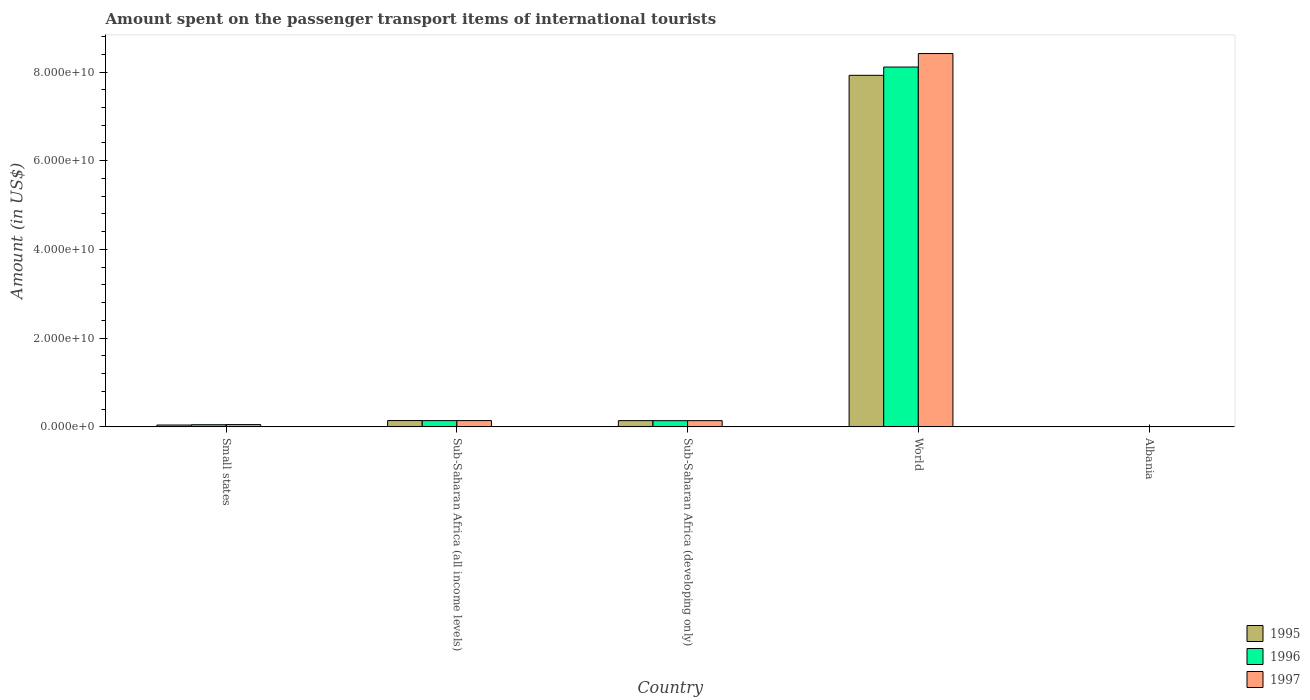Are the number of bars on each tick of the X-axis equal?
Make the answer very short. Yes. What is the label of the 1st group of bars from the left?
Ensure brevity in your answer.  Small states. In how many cases, is the number of bars for a given country not equal to the number of legend labels?
Ensure brevity in your answer.  0. What is the amount spent on the passenger transport items of international tourists in 1996 in World?
Give a very brief answer. 8.11e+1. Across all countries, what is the maximum amount spent on the passenger transport items of international tourists in 1997?
Your answer should be very brief. 8.42e+1. Across all countries, what is the minimum amount spent on the passenger transport items of international tourists in 1996?
Ensure brevity in your answer.  1.30e+07. In which country was the amount spent on the passenger transport items of international tourists in 1997 minimum?
Your answer should be very brief. Albania. What is the total amount spent on the passenger transport items of international tourists in 1995 in the graph?
Ensure brevity in your answer.  8.25e+1. What is the difference between the amount spent on the passenger transport items of international tourists in 1997 in Albania and that in Sub-Saharan Africa (developing only)?
Ensure brevity in your answer.  -1.39e+09. What is the difference between the amount spent on the passenger transport items of international tourists in 1995 in Albania and the amount spent on the passenger transport items of international tourists in 1996 in Sub-Saharan Africa (all income levels)?
Your answer should be compact. -1.40e+09. What is the average amount spent on the passenger transport items of international tourists in 1997 per country?
Provide a short and direct response. 1.75e+1. What is the difference between the amount spent on the passenger transport items of international tourists of/in 1995 and amount spent on the passenger transport items of international tourists of/in 1997 in Small states?
Make the answer very short. -9.94e+07. What is the ratio of the amount spent on the passenger transport items of international tourists in 1996 in Albania to that in World?
Your answer should be compact. 0. Is the amount spent on the passenger transport items of international tourists in 1997 in Sub-Saharan Africa (all income levels) less than that in World?
Provide a short and direct response. Yes. What is the difference between the highest and the second highest amount spent on the passenger transport items of international tourists in 1997?
Your answer should be very brief. 8.27e+1. What is the difference between the highest and the lowest amount spent on the passenger transport items of international tourists in 1996?
Your response must be concise. 8.11e+1. In how many countries, is the amount spent on the passenger transport items of international tourists in 1995 greater than the average amount spent on the passenger transport items of international tourists in 1995 taken over all countries?
Provide a short and direct response. 1. What does the 2nd bar from the left in Small states represents?
Your answer should be very brief. 1996. How many bars are there?
Make the answer very short. 15. Are all the bars in the graph horizontal?
Make the answer very short. No. How many countries are there in the graph?
Your answer should be very brief. 5. What is the difference between two consecutive major ticks on the Y-axis?
Give a very brief answer. 2.00e+1. Does the graph contain any zero values?
Ensure brevity in your answer.  No. Does the graph contain grids?
Provide a short and direct response. No. What is the title of the graph?
Offer a terse response. Amount spent on the passenger transport items of international tourists. What is the label or title of the X-axis?
Keep it short and to the point. Country. What is the label or title of the Y-axis?
Provide a succinct answer. Amount (in US$). What is the Amount (in US$) of 1995 in Small states?
Offer a terse response. 4.15e+08. What is the Amount (in US$) of 1996 in Small states?
Provide a short and direct response. 4.85e+08. What is the Amount (in US$) of 1997 in Small states?
Offer a very short reply. 5.15e+08. What is the Amount (in US$) of 1995 in Sub-Saharan Africa (all income levels)?
Offer a terse response. 1.42e+09. What is the Amount (in US$) of 1996 in Sub-Saharan Africa (all income levels)?
Provide a succinct answer. 1.41e+09. What is the Amount (in US$) of 1997 in Sub-Saharan Africa (all income levels)?
Keep it short and to the point. 1.42e+09. What is the Amount (in US$) of 1995 in Sub-Saharan Africa (developing only)?
Provide a succinct answer. 1.41e+09. What is the Amount (in US$) of 1996 in Sub-Saharan Africa (developing only)?
Keep it short and to the point. 1.40e+09. What is the Amount (in US$) of 1997 in Sub-Saharan Africa (developing only)?
Offer a terse response. 1.40e+09. What is the Amount (in US$) of 1995 in World?
Offer a terse response. 7.93e+1. What is the Amount (in US$) of 1996 in World?
Your answer should be compact. 8.11e+1. What is the Amount (in US$) of 1997 in World?
Provide a short and direct response. 8.42e+1. What is the Amount (in US$) of 1995 in Albania?
Provide a short and direct response. 1.20e+07. What is the Amount (in US$) in 1996 in Albania?
Keep it short and to the point. 1.30e+07. Across all countries, what is the maximum Amount (in US$) of 1995?
Provide a succinct answer. 7.93e+1. Across all countries, what is the maximum Amount (in US$) in 1996?
Ensure brevity in your answer.  8.11e+1. Across all countries, what is the maximum Amount (in US$) of 1997?
Your response must be concise. 8.42e+1. Across all countries, what is the minimum Amount (in US$) in 1996?
Make the answer very short. 1.30e+07. What is the total Amount (in US$) of 1995 in the graph?
Your answer should be compact. 8.25e+1. What is the total Amount (in US$) in 1996 in the graph?
Ensure brevity in your answer.  8.44e+1. What is the total Amount (in US$) in 1997 in the graph?
Your answer should be very brief. 8.75e+1. What is the difference between the Amount (in US$) in 1995 in Small states and that in Sub-Saharan Africa (all income levels)?
Your response must be concise. -1.01e+09. What is the difference between the Amount (in US$) of 1996 in Small states and that in Sub-Saharan Africa (all income levels)?
Your answer should be very brief. -9.28e+08. What is the difference between the Amount (in US$) in 1997 in Small states and that in Sub-Saharan Africa (all income levels)?
Your answer should be very brief. -9.01e+08. What is the difference between the Amount (in US$) in 1995 in Small states and that in Sub-Saharan Africa (developing only)?
Your answer should be very brief. -9.90e+08. What is the difference between the Amount (in US$) of 1996 in Small states and that in Sub-Saharan Africa (developing only)?
Give a very brief answer. -9.14e+08. What is the difference between the Amount (in US$) of 1997 in Small states and that in Sub-Saharan Africa (developing only)?
Ensure brevity in your answer.  -8.87e+08. What is the difference between the Amount (in US$) of 1995 in Small states and that in World?
Provide a succinct answer. -7.88e+1. What is the difference between the Amount (in US$) in 1996 in Small states and that in World?
Give a very brief answer. -8.06e+1. What is the difference between the Amount (in US$) of 1997 in Small states and that in World?
Your response must be concise. -8.36e+1. What is the difference between the Amount (in US$) in 1995 in Small states and that in Albania?
Keep it short and to the point. 4.03e+08. What is the difference between the Amount (in US$) of 1996 in Small states and that in Albania?
Provide a short and direct response. 4.72e+08. What is the difference between the Amount (in US$) of 1997 in Small states and that in Albania?
Your answer should be very brief. 5.07e+08. What is the difference between the Amount (in US$) in 1995 in Sub-Saharan Africa (all income levels) and that in Sub-Saharan Africa (developing only)?
Keep it short and to the point. 1.78e+07. What is the difference between the Amount (in US$) in 1996 in Sub-Saharan Africa (all income levels) and that in Sub-Saharan Africa (developing only)?
Ensure brevity in your answer.  1.43e+07. What is the difference between the Amount (in US$) of 1997 in Sub-Saharan Africa (all income levels) and that in Sub-Saharan Africa (developing only)?
Make the answer very short. 1.43e+07. What is the difference between the Amount (in US$) of 1995 in Sub-Saharan Africa (all income levels) and that in World?
Offer a terse response. -7.78e+1. What is the difference between the Amount (in US$) in 1996 in Sub-Saharan Africa (all income levels) and that in World?
Give a very brief answer. -7.97e+1. What is the difference between the Amount (in US$) in 1997 in Sub-Saharan Africa (all income levels) and that in World?
Your answer should be very brief. -8.27e+1. What is the difference between the Amount (in US$) of 1995 in Sub-Saharan Africa (all income levels) and that in Albania?
Keep it short and to the point. 1.41e+09. What is the difference between the Amount (in US$) in 1996 in Sub-Saharan Africa (all income levels) and that in Albania?
Offer a terse response. 1.40e+09. What is the difference between the Amount (in US$) in 1997 in Sub-Saharan Africa (all income levels) and that in Albania?
Your response must be concise. 1.41e+09. What is the difference between the Amount (in US$) of 1995 in Sub-Saharan Africa (developing only) and that in World?
Keep it short and to the point. -7.78e+1. What is the difference between the Amount (in US$) in 1996 in Sub-Saharan Africa (developing only) and that in World?
Your answer should be very brief. -7.97e+1. What is the difference between the Amount (in US$) of 1997 in Sub-Saharan Africa (developing only) and that in World?
Keep it short and to the point. -8.28e+1. What is the difference between the Amount (in US$) of 1995 in Sub-Saharan Africa (developing only) and that in Albania?
Give a very brief answer. 1.39e+09. What is the difference between the Amount (in US$) of 1996 in Sub-Saharan Africa (developing only) and that in Albania?
Offer a terse response. 1.39e+09. What is the difference between the Amount (in US$) of 1997 in Sub-Saharan Africa (developing only) and that in Albania?
Your answer should be very brief. 1.39e+09. What is the difference between the Amount (in US$) of 1995 in World and that in Albania?
Provide a short and direct response. 7.92e+1. What is the difference between the Amount (in US$) in 1996 in World and that in Albania?
Offer a terse response. 8.11e+1. What is the difference between the Amount (in US$) in 1997 in World and that in Albania?
Give a very brief answer. 8.42e+1. What is the difference between the Amount (in US$) in 1995 in Small states and the Amount (in US$) in 1996 in Sub-Saharan Africa (all income levels)?
Provide a short and direct response. -9.98e+08. What is the difference between the Amount (in US$) of 1995 in Small states and the Amount (in US$) of 1997 in Sub-Saharan Africa (all income levels)?
Give a very brief answer. -1.00e+09. What is the difference between the Amount (in US$) in 1996 in Small states and the Amount (in US$) in 1997 in Sub-Saharan Africa (all income levels)?
Give a very brief answer. -9.31e+08. What is the difference between the Amount (in US$) in 1995 in Small states and the Amount (in US$) in 1996 in Sub-Saharan Africa (developing only)?
Offer a terse response. -9.84e+08. What is the difference between the Amount (in US$) in 1995 in Small states and the Amount (in US$) in 1997 in Sub-Saharan Africa (developing only)?
Give a very brief answer. -9.86e+08. What is the difference between the Amount (in US$) in 1996 in Small states and the Amount (in US$) in 1997 in Sub-Saharan Africa (developing only)?
Your answer should be compact. -9.17e+08. What is the difference between the Amount (in US$) of 1995 in Small states and the Amount (in US$) of 1996 in World?
Offer a very short reply. -8.07e+1. What is the difference between the Amount (in US$) in 1995 in Small states and the Amount (in US$) in 1997 in World?
Your answer should be very brief. -8.37e+1. What is the difference between the Amount (in US$) in 1996 in Small states and the Amount (in US$) in 1997 in World?
Make the answer very short. -8.37e+1. What is the difference between the Amount (in US$) in 1995 in Small states and the Amount (in US$) in 1996 in Albania?
Give a very brief answer. 4.02e+08. What is the difference between the Amount (in US$) of 1995 in Small states and the Amount (in US$) of 1997 in Albania?
Make the answer very short. 4.07e+08. What is the difference between the Amount (in US$) of 1996 in Small states and the Amount (in US$) of 1997 in Albania?
Give a very brief answer. 4.77e+08. What is the difference between the Amount (in US$) in 1995 in Sub-Saharan Africa (all income levels) and the Amount (in US$) in 1996 in Sub-Saharan Africa (developing only)?
Your answer should be compact. 2.39e+07. What is the difference between the Amount (in US$) in 1995 in Sub-Saharan Africa (all income levels) and the Amount (in US$) in 1997 in Sub-Saharan Africa (developing only)?
Your answer should be very brief. 2.14e+07. What is the difference between the Amount (in US$) in 1996 in Sub-Saharan Africa (all income levels) and the Amount (in US$) in 1997 in Sub-Saharan Africa (developing only)?
Make the answer very short. 1.18e+07. What is the difference between the Amount (in US$) in 1995 in Sub-Saharan Africa (all income levels) and the Amount (in US$) in 1996 in World?
Provide a succinct answer. -7.97e+1. What is the difference between the Amount (in US$) in 1995 in Sub-Saharan Africa (all income levels) and the Amount (in US$) in 1997 in World?
Your answer should be very brief. -8.27e+1. What is the difference between the Amount (in US$) in 1996 in Sub-Saharan Africa (all income levels) and the Amount (in US$) in 1997 in World?
Offer a very short reply. -8.27e+1. What is the difference between the Amount (in US$) of 1995 in Sub-Saharan Africa (all income levels) and the Amount (in US$) of 1996 in Albania?
Keep it short and to the point. 1.41e+09. What is the difference between the Amount (in US$) in 1995 in Sub-Saharan Africa (all income levels) and the Amount (in US$) in 1997 in Albania?
Ensure brevity in your answer.  1.42e+09. What is the difference between the Amount (in US$) of 1996 in Sub-Saharan Africa (all income levels) and the Amount (in US$) of 1997 in Albania?
Your response must be concise. 1.41e+09. What is the difference between the Amount (in US$) in 1995 in Sub-Saharan Africa (developing only) and the Amount (in US$) in 1996 in World?
Ensure brevity in your answer.  -7.97e+1. What is the difference between the Amount (in US$) in 1995 in Sub-Saharan Africa (developing only) and the Amount (in US$) in 1997 in World?
Give a very brief answer. -8.28e+1. What is the difference between the Amount (in US$) of 1996 in Sub-Saharan Africa (developing only) and the Amount (in US$) of 1997 in World?
Give a very brief answer. -8.28e+1. What is the difference between the Amount (in US$) of 1995 in Sub-Saharan Africa (developing only) and the Amount (in US$) of 1996 in Albania?
Make the answer very short. 1.39e+09. What is the difference between the Amount (in US$) in 1995 in Sub-Saharan Africa (developing only) and the Amount (in US$) in 1997 in Albania?
Give a very brief answer. 1.40e+09. What is the difference between the Amount (in US$) in 1996 in Sub-Saharan Africa (developing only) and the Amount (in US$) in 1997 in Albania?
Your response must be concise. 1.39e+09. What is the difference between the Amount (in US$) in 1995 in World and the Amount (in US$) in 1996 in Albania?
Your response must be concise. 7.92e+1. What is the difference between the Amount (in US$) of 1995 in World and the Amount (in US$) of 1997 in Albania?
Make the answer very short. 7.92e+1. What is the difference between the Amount (in US$) of 1996 in World and the Amount (in US$) of 1997 in Albania?
Your answer should be very brief. 8.11e+1. What is the average Amount (in US$) of 1995 per country?
Ensure brevity in your answer.  1.65e+1. What is the average Amount (in US$) of 1996 per country?
Offer a very short reply. 1.69e+1. What is the average Amount (in US$) of 1997 per country?
Provide a short and direct response. 1.75e+1. What is the difference between the Amount (in US$) of 1995 and Amount (in US$) of 1996 in Small states?
Offer a terse response. -6.97e+07. What is the difference between the Amount (in US$) of 1995 and Amount (in US$) of 1997 in Small states?
Offer a very short reply. -9.94e+07. What is the difference between the Amount (in US$) of 1996 and Amount (in US$) of 1997 in Small states?
Your answer should be very brief. -2.97e+07. What is the difference between the Amount (in US$) in 1995 and Amount (in US$) in 1996 in Sub-Saharan Africa (all income levels)?
Offer a terse response. 9.58e+06. What is the difference between the Amount (in US$) in 1995 and Amount (in US$) in 1997 in Sub-Saharan Africa (all income levels)?
Your response must be concise. 7.08e+06. What is the difference between the Amount (in US$) in 1996 and Amount (in US$) in 1997 in Sub-Saharan Africa (all income levels)?
Keep it short and to the point. -2.51e+06. What is the difference between the Amount (in US$) in 1995 and Amount (in US$) in 1996 in Sub-Saharan Africa (developing only)?
Offer a very short reply. 6.01e+06. What is the difference between the Amount (in US$) of 1995 and Amount (in US$) of 1997 in Sub-Saharan Africa (developing only)?
Ensure brevity in your answer.  3.52e+06. What is the difference between the Amount (in US$) in 1996 and Amount (in US$) in 1997 in Sub-Saharan Africa (developing only)?
Give a very brief answer. -2.49e+06. What is the difference between the Amount (in US$) in 1995 and Amount (in US$) in 1996 in World?
Your answer should be compact. -1.87e+09. What is the difference between the Amount (in US$) in 1995 and Amount (in US$) in 1997 in World?
Provide a short and direct response. -4.91e+09. What is the difference between the Amount (in US$) of 1996 and Amount (in US$) of 1997 in World?
Your response must be concise. -3.04e+09. What is the difference between the Amount (in US$) of 1995 and Amount (in US$) of 1997 in Albania?
Give a very brief answer. 4.00e+06. What is the difference between the Amount (in US$) of 1996 and Amount (in US$) of 1997 in Albania?
Make the answer very short. 5.00e+06. What is the ratio of the Amount (in US$) of 1995 in Small states to that in Sub-Saharan Africa (all income levels)?
Your answer should be very brief. 0.29. What is the ratio of the Amount (in US$) of 1996 in Small states to that in Sub-Saharan Africa (all income levels)?
Offer a very short reply. 0.34. What is the ratio of the Amount (in US$) of 1997 in Small states to that in Sub-Saharan Africa (all income levels)?
Provide a succinct answer. 0.36. What is the ratio of the Amount (in US$) in 1995 in Small states to that in Sub-Saharan Africa (developing only)?
Provide a succinct answer. 0.3. What is the ratio of the Amount (in US$) in 1996 in Small states to that in Sub-Saharan Africa (developing only)?
Provide a succinct answer. 0.35. What is the ratio of the Amount (in US$) in 1997 in Small states to that in Sub-Saharan Africa (developing only)?
Ensure brevity in your answer.  0.37. What is the ratio of the Amount (in US$) of 1995 in Small states to that in World?
Your response must be concise. 0.01. What is the ratio of the Amount (in US$) in 1996 in Small states to that in World?
Make the answer very short. 0.01. What is the ratio of the Amount (in US$) in 1997 in Small states to that in World?
Make the answer very short. 0.01. What is the ratio of the Amount (in US$) in 1995 in Small states to that in Albania?
Your answer should be compact. 34.62. What is the ratio of the Amount (in US$) of 1996 in Small states to that in Albania?
Offer a very short reply. 37.32. What is the ratio of the Amount (in US$) in 1997 in Small states to that in Albania?
Ensure brevity in your answer.  64.36. What is the ratio of the Amount (in US$) of 1995 in Sub-Saharan Africa (all income levels) to that in Sub-Saharan Africa (developing only)?
Your response must be concise. 1.01. What is the ratio of the Amount (in US$) of 1996 in Sub-Saharan Africa (all income levels) to that in Sub-Saharan Africa (developing only)?
Your answer should be compact. 1.01. What is the ratio of the Amount (in US$) in 1997 in Sub-Saharan Africa (all income levels) to that in Sub-Saharan Africa (developing only)?
Give a very brief answer. 1.01. What is the ratio of the Amount (in US$) of 1995 in Sub-Saharan Africa (all income levels) to that in World?
Your response must be concise. 0.02. What is the ratio of the Amount (in US$) in 1996 in Sub-Saharan Africa (all income levels) to that in World?
Provide a succinct answer. 0.02. What is the ratio of the Amount (in US$) in 1997 in Sub-Saharan Africa (all income levels) to that in World?
Make the answer very short. 0.02. What is the ratio of the Amount (in US$) of 1995 in Sub-Saharan Africa (all income levels) to that in Albania?
Make the answer very short. 118.6. What is the ratio of the Amount (in US$) in 1996 in Sub-Saharan Africa (all income levels) to that in Albania?
Give a very brief answer. 108.74. What is the ratio of the Amount (in US$) in 1997 in Sub-Saharan Africa (all income levels) to that in Albania?
Offer a terse response. 177.02. What is the ratio of the Amount (in US$) of 1995 in Sub-Saharan Africa (developing only) to that in World?
Provide a succinct answer. 0.02. What is the ratio of the Amount (in US$) of 1996 in Sub-Saharan Africa (developing only) to that in World?
Provide a short and direct response. 0.02. What is the ratio of the Amount (in US$) of 1997 in Sub-Saharan Africa (developing only) to that in World?
Provide a succinct answer. 0.02. What is the ratio of the Amount (in US$) in 1995 in Sub-Saharan Africa (developing only) to that in Albania?
Offer a very short reply. 117.11. What is the ratio of the Amount (in US$) in 1996 in Sub-Saharan Africa (developing only) to that in Albania?
Offer a terse response. 107.64. What is the ratio of the Amount (in US$) of 1997 in Sub-Saharan Africa (developing only) to that in Albania?
Offer a very short reply. 175.23. What is the ratio of the Amount (in US$) in 1995 in World to that in Albania?
Make the answer very short. 6604.42. What is the ratio of the Amount (in US$) of 1996 in World to that in Albania?
Offer a very short reply. 6239.88. What is the ratio of the Amount (in US$) in 1997 in World to that in Albania?
Your response must be concise. 1.05e+04. What is the difference between the highest and the second highest Amount (in US$) in 1995?
Your answer should be compact. 7.78e+1. What is the difference between the highest and the second highest Amount (in US$) of 1996?
Provide a succinct answer. 7.97e+1. What is the difference between the highest and the second highest Amount (in US$) of 1997?
Make the answer very short. 8.27e+1. What is the difference between the highest and the lowest Amount (in US$) of 1995?
Ensure brevity in your answer.  7.92e+1. What is the difference between the highest and the lowest Amount (in US$) in 1996?
Ensure brevity in your answer.  8.11e+1. What is the difference between the highest and the lowest Amount (in US$) in 1997?
Your answer should be very brief. 8.42e+1. 